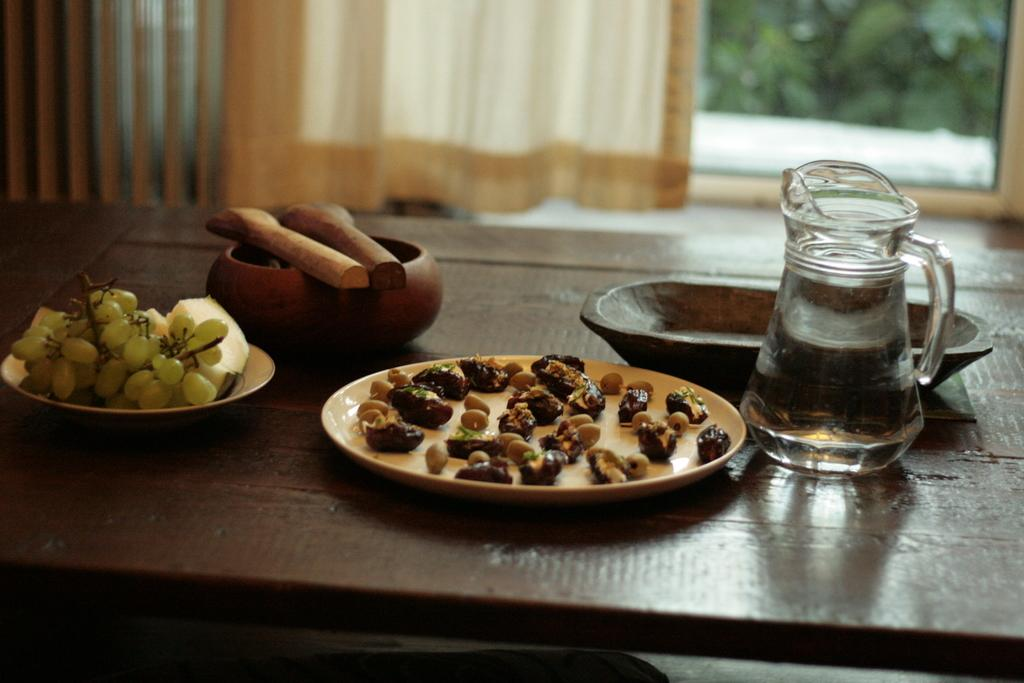What is placed on the table in the image? There is a tray, a bowl, and plates on the table. What is in the bowl on the table? The bowl on the table contains fruits and food. What is the purpose of the jar on the table? The jar on the table contains water. What can be seen through the window in the image? A tree is visible through the window. What type of window treatment is present in the image? There is a curtain associated with the window. What type of tank can be seen in the image? There is no tank present in the image. What country is depicted in the image? The image does not depict a specific country; it shows a table with various items and a window with a tree outside. 